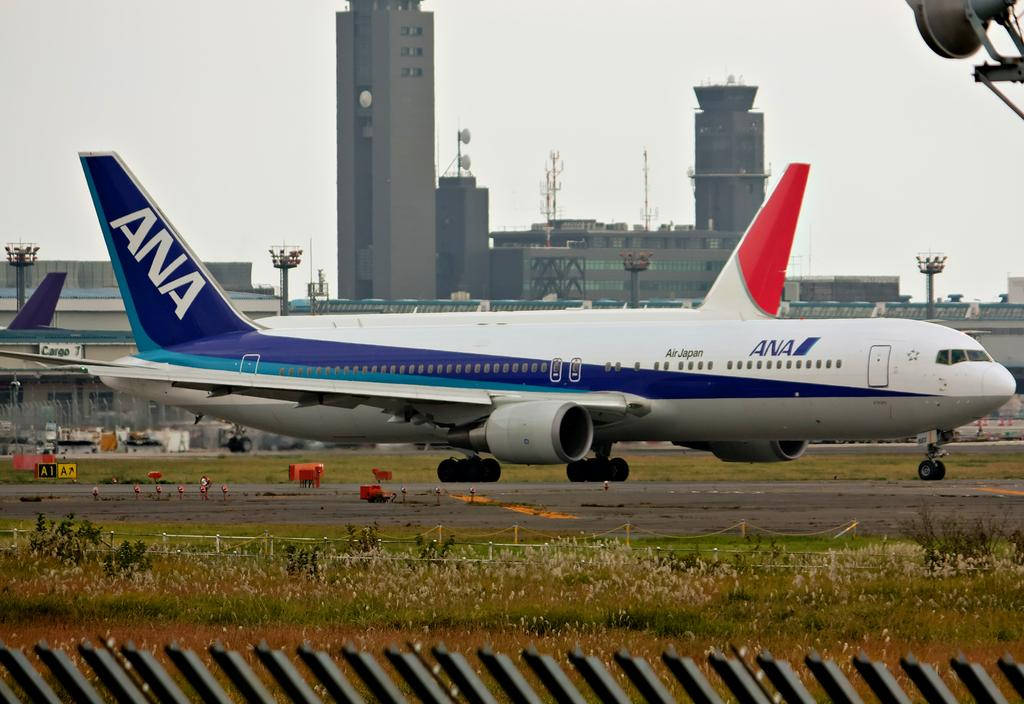What can be seen on the runway in the image? There are aeroplanes on the runway in the image. What type of structures are present in the image? There are buildings and towers in the image. What type of lighting is present in the image? There are pole lights in the image. What type of vegetation is present in the image? There are plants in the image. What is the condition of the sky in the image? The sky is cloudy in the image. Where are the cows grazing in the image? There are no cows present in the image. What type of park can be seen in the image? There is no park present in the image. 